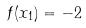Convert formula to latex. <formula><loc_0><loc_0><loc_500><loc_500>f ( x _ { 1 } ) = - 2</formula> 